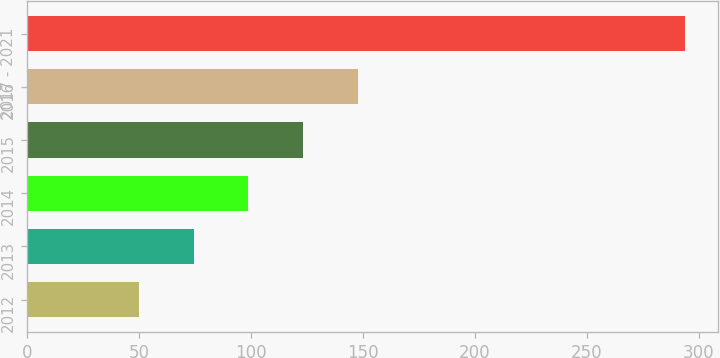Convert chart to OTSL. <chart><loc_0><loc_0><loc_500><loc_500><bar_chart><fcel>2012<fcel>2013<fcel>2014<fcel>2015<fcel>2016<fcel>2017 - 2021<nl><fcel>50<fcel>74.4<fcel>98.8<fcel>123.2<fcel>147.6<fcel>294<nl></chart> 